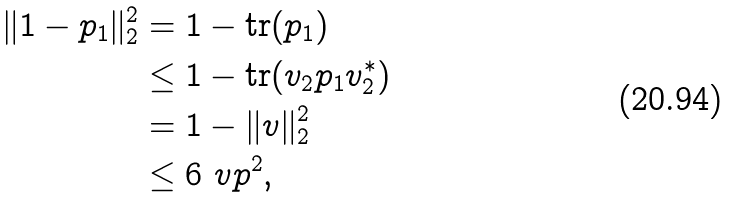<formula> <loc_0><loc_0><loc_500><loc_500>\| 1 - p _ { 1 } \| ^ { 2 } _ { 2 } & = 1 - \text {tr} ( p _ { 1 } ) \\ & \leq 1 - \text {tr} ( v _ { 2 } p _ { 1 } v ^ { * } _ { 2 } ) \\ & = 1 - \| v \| ^ { 2 } _ { 2 } \\ & \leq 6 \ v p ^ { 2 } ,</formula> 